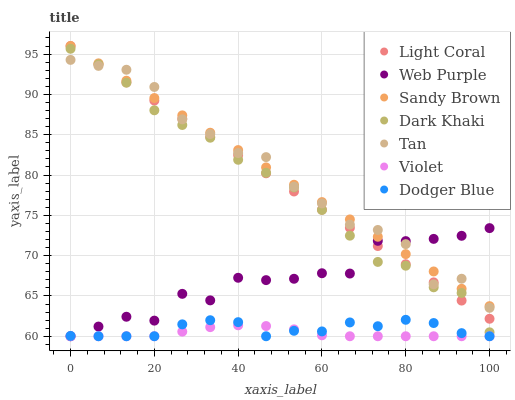Does Violet have the minimum area under the curve?
Answer yes or no. Yes. Does Tan have the maximum area under the curve?
Answer yes or no. Yes. Does Light Coral have the minimum area under the curve?
Answer yes or no. No. Does Light Coral have the maximum area under the curve?
Answer yes or no. No. Is Sandy Brown the smoothest?
Answer yes or no. Yes. Is Tan the roughest?
Answer yes or no. Yes. Is Light Coral the smoothest?
Answer yes or no. No. Is Light Coral the roughest?
Answer yes or no. No. Does Web Purple have the lowest value?
Answer yes or no. Yes. Does Light Coral have the lowest value?
Answer yes or no. No. Does Sandy Brown have the highest value?
Answer yes or no. Yes. Does Web Purple have the highest value?
Answer yes or no. No. Is Dodger Blue less than Dark Khaki?
Answer yes or no. Yes. Is Dark Khaki greater than Dodger Blue?
Answer yes or no. Yes. Does Web Purple intersect Dark Khaki?
Answer yes or no. Yes. Is Web Purple less than Dark Khaki?
Answer yes or no. No. Is Web Purple greater than Dark Khaki?
Answer yes or no. No. Does Dodger Blue intersect Dark Khaki?
Answer yes or no. No. 